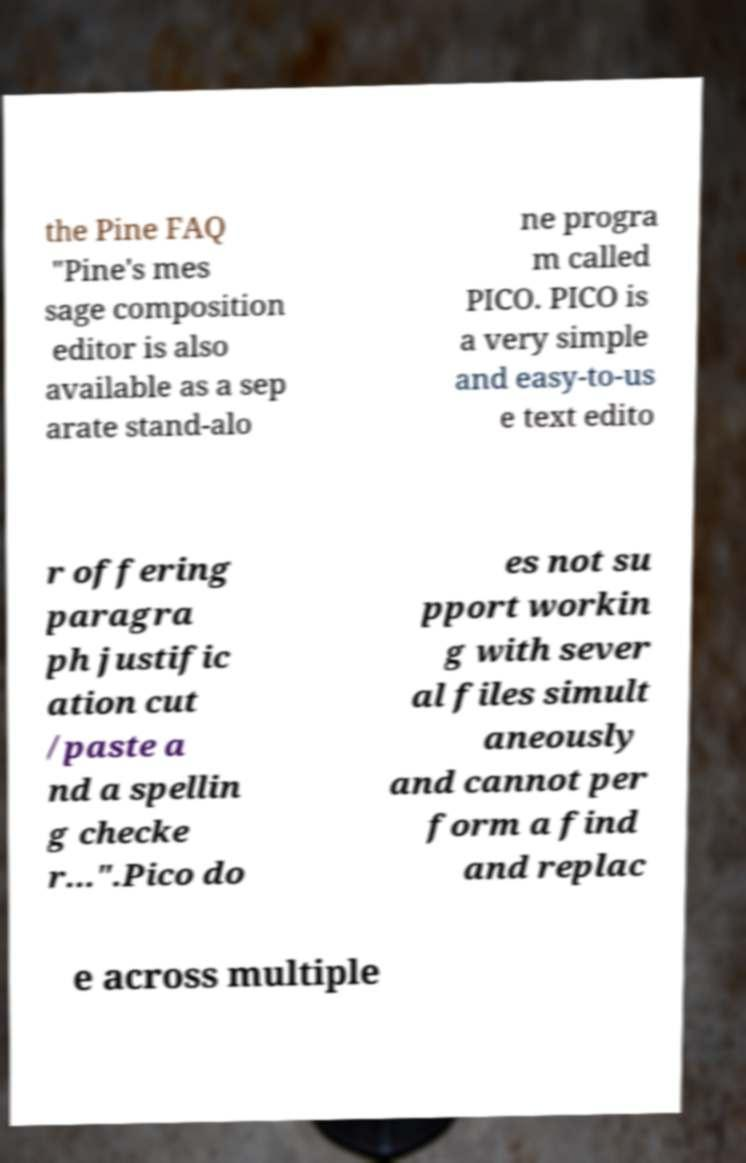Could you assist in decoding the text presented in this image and type it out clearly? the Pine FAQ "Pine's mes sage composition editor is also available as a sep arate stand-alo ne progra m called PICO. PICO is a very simple and easy-to-us e text edito r offering paragra ph justific ation cut /paste a nd a spellin g checke r...".Pico do es not su pport workin g with sever al files simult aneously and cannot per form a find and replac e across multiple 